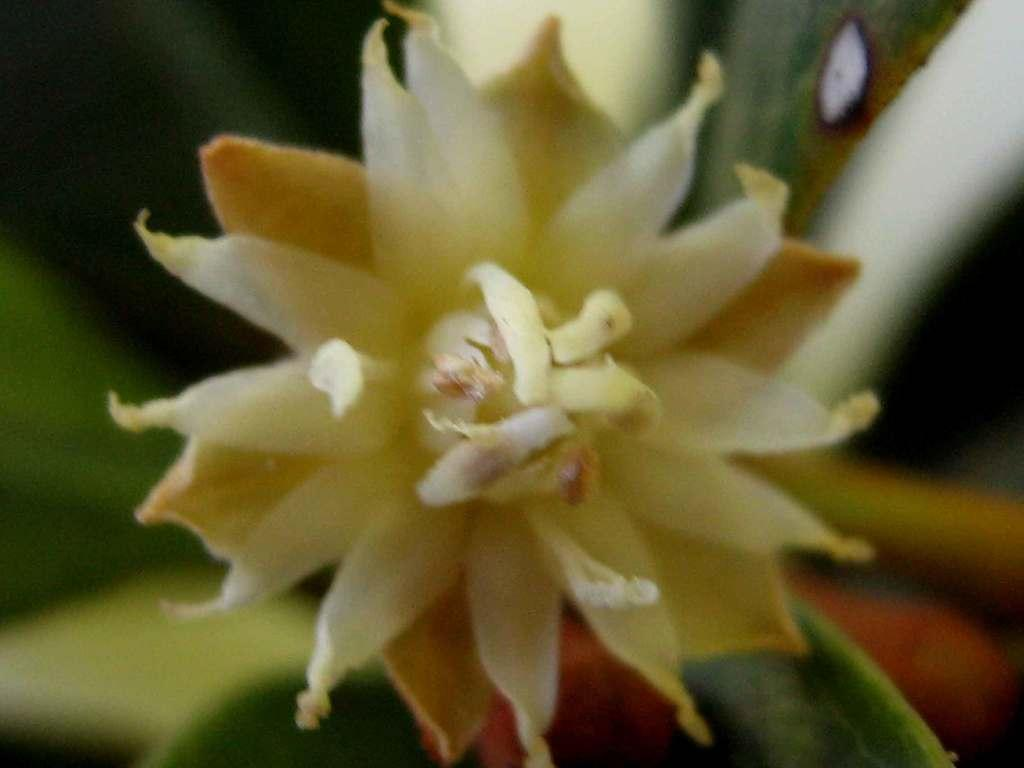What is the main subject of the image? There is a flower in the image. Can you describe the flower in the image? Unfortunately, the facts provided do not give any details about the flower's appearance. Is there anything else in the image besides the flower? The facts provided do not mention any other objects or subjects in the image. What type of interest does the flower have in the image? The flower is not capable of having interests, as it is a non-living object. 